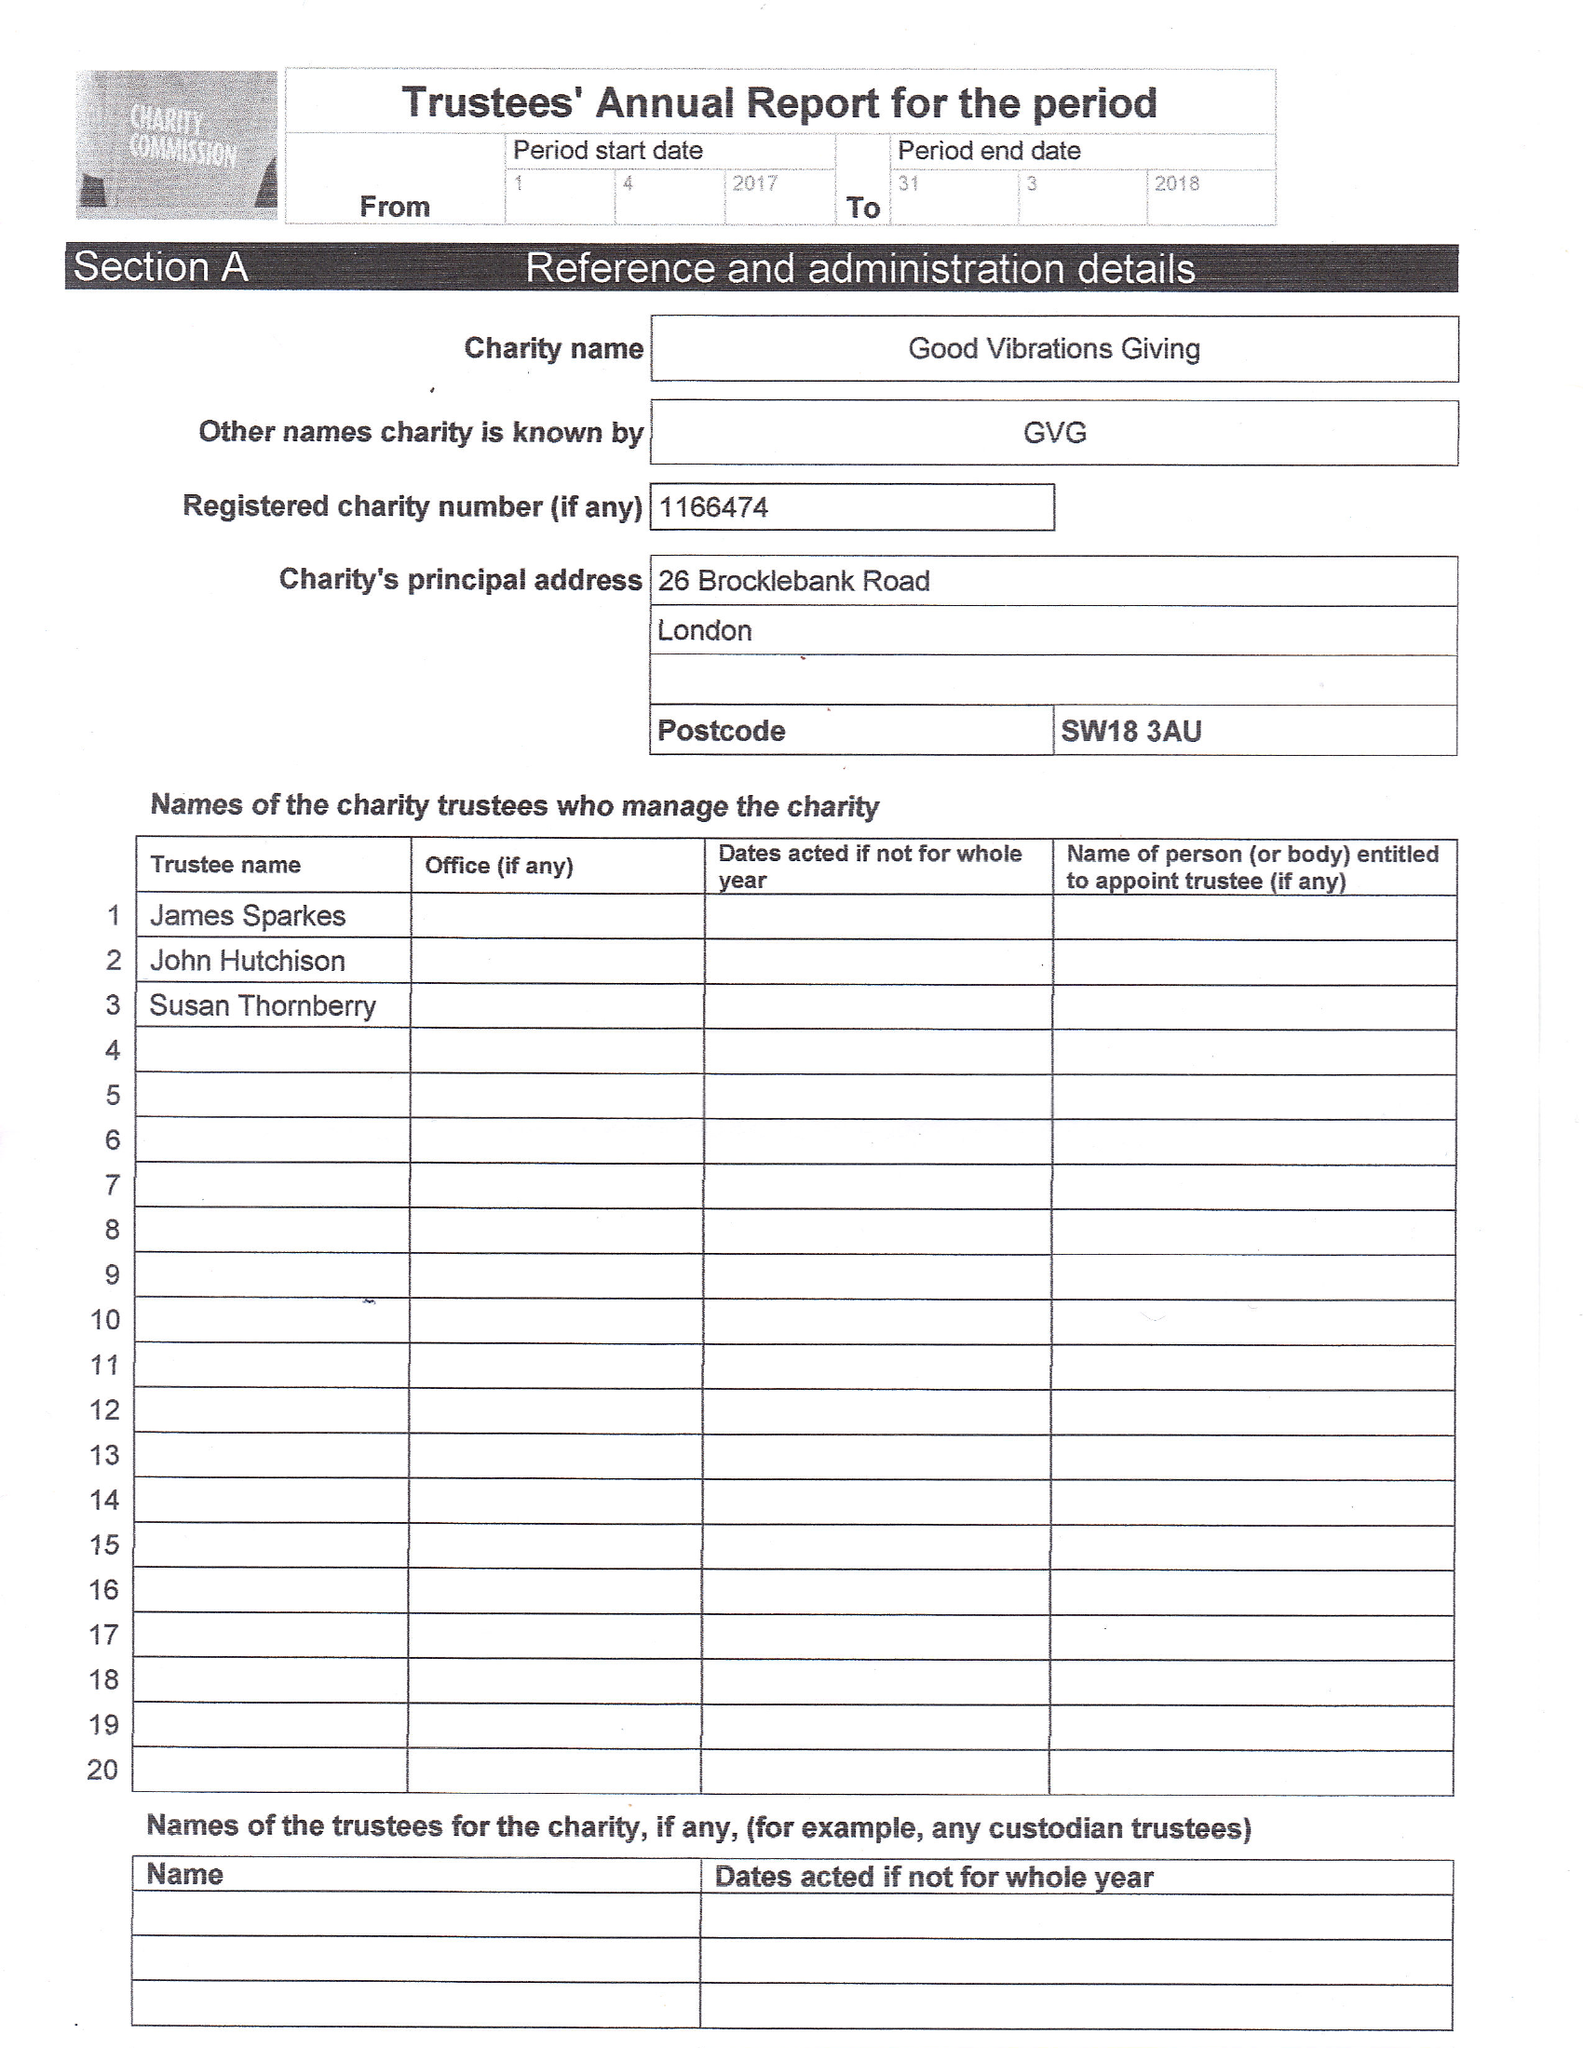What is the value for the charity_number?
Answer the question using a single word or phrase. 1166474 